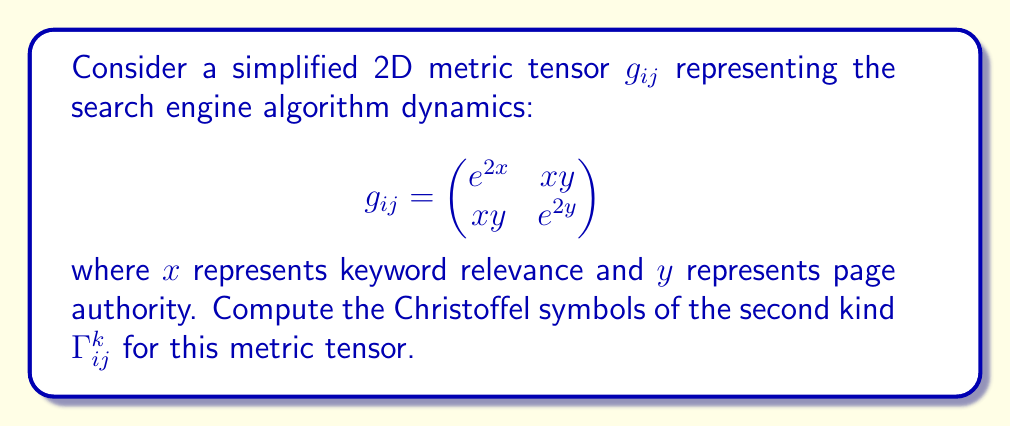Show me your answer to this math problem. To compute the Christoffel symbols, we'll follow these steps:

1) First, recall the formula for Christoffel symbols of the second kind:

   $$\Gamma^k_{ij} = \frac{1}{2}g^{kl}\left(\frac{\partial g_{jl}}{\partial x^i} + \frac{\partial g_{il}}{\partial x^j} - \frac{\partial g_{ij}}{\partial x^l}\right)$$

2) Calculate the inverse metric tensor $g^{ij}$:
   
   $$g^{ij} = \frac{1}{\det(g_{ij})}\begin{pmatrix}
   e^{2y} & -xy \\
   -xy & e^{2x}
   \end{pmatrix}$$

   where $\det(g_{ij}) = e^{2x+2y} - x^2y^2$

3) Calculate the partial derivatives:

   $\frac{\partial g_{11}}{\partial x} = 2e^{2x}$, $\frac{\partial g_{11}}{\partial y} = 0$
   $\frac{\partial g_{12}}{\partial x} = y$, $\frac{\partial g_{12}}{\partial y} = x$
   $\frac{\partial g_{22}}{\partial x} = 0$, $\frac{\partial g_{22}}{\partial y} = 2e^{2y}$

4) Now, let's compute each Christoffel symbol:

   $\Gamma^1_{11} = \frac{1}{2}(g^{11}\cdot 2e^{2x} + g^{11}\cdot 2e^{2x} - g^{11}\cdot 2e^{2x}) = g^{11}e^{2x} = \frac{e^{2y+2x}}{e^{2x+2y} - x^2y^2}$

   $\Gamma^1_{12} = \frac{1}{2}(g^{11}\cdot y + g^{12}\cdot 2e^{2x} - g^{11}\cdot y) = g^{12}e^{2x} = \frac{-xye^{2x}}{e^{2x+2y} - x^2y^2}$

   $\Gamma^1_{22} = \frac{1}{2}(g^{11}\cdot 0 + g^{12}\cdot 2e^{2y} - g^{12}\cdot 0) = g^{12}e^{2y} = \frac{-xye^{2y}}{e^{2x+2y} - x^2y^2}$

   $\Gamma^2_{11} = \frac{1}{2}(g^{21}\cdot 2e^{2x} + g^{21}\cdot 2e^{2x} - g^{21}\cdot 2e^{2x}) = g^{21}e^{2x} = \frac{-xye^{2x}}{e^{2x+2y} - x^2y^2}$

   $\Gamma^2_{12} = \frac{1}{2}(g^{21}\cdot y + g^{22}\cdot 2e^{2x} - g^{21}\cdot x) = \frac{1}{2}(g^{21}y + g^{22}2e^{2x} - g^{21}x) = \frac{ye^{2x} - x^3y}{2(e^{2x+2y} - x^2y^2)}$

   $\Gamma^2_{22} = \frac{1}{2}(g^{21}\cdot 0 + g^{22}\cdot 2e^{2y} - g^{22}\cdot 2e^{2y}) = g^{22}e^{2y} = \frac{e^{2x+2y}}{e^{2x+2y} - x^2y^2}$
Answer: $$\Gamma^1_{11} = \frac{e^{2y+2x}}{e^{2x+2y} - x^2y^2}, \Gamma^1_{12} = \frac{-xye^{2x}}{e^{2x+2y} - x^2y^2}, \Gamma^1_{22} = \frac{-xye^{2y}}{e^{2x+2y} - x^2y^2}$$
$$\Gamma^2_{11} = \frac{-xye^{2x}}{e^{2x+2y} - x^2y^2}, \Gamma^2_{12} = \frac{ye^{2x} - x^3y}{2(e^{2x+2y} - x^2y^2)}, \Gamma^2_{22} = \frac{e^{2x+2y}}{e^{2x+2y} - x^2y^2}$$ 